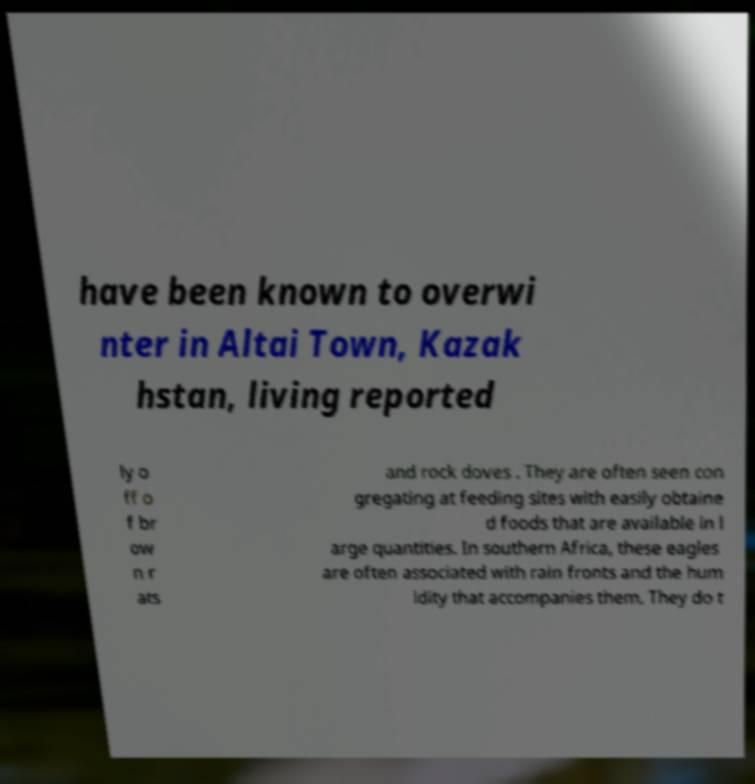Please identify and transcribe the text found in this image. have been known to overwi nter in Altai Town, Kazak hstan, living reported ly o ff o f br ow n r ats and rock doves . They are often seen con gregating at feeding sites with easily obtaine d foods that are available in l arge quantities. In southern Africa, these eagles are often associated with rain fronts and the hum idity that accompanies them. They do t 